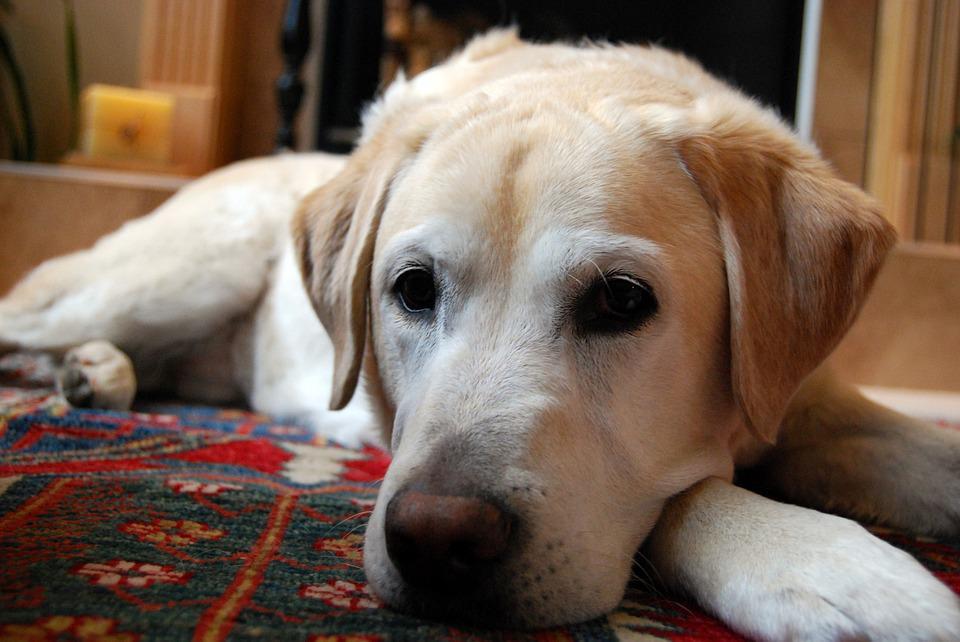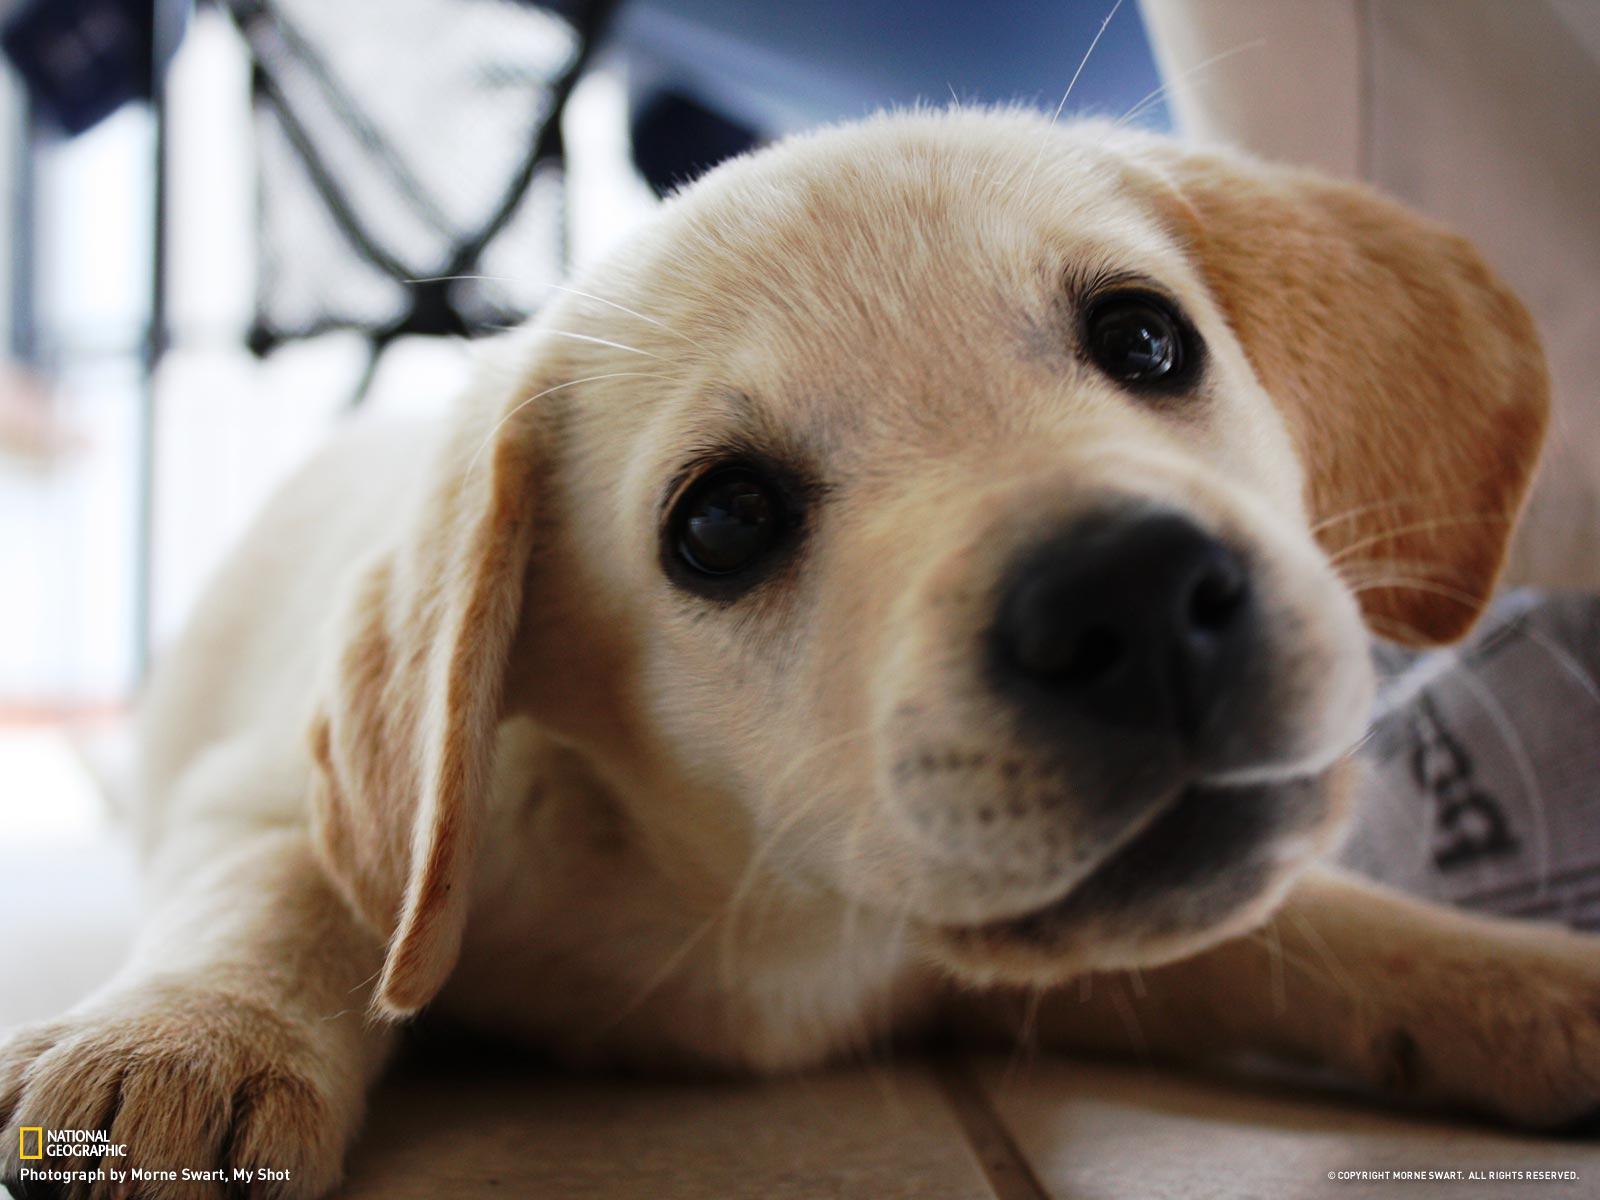The first image is the image on the left, the second image is the image on the right. For the images displayed, is the sentence "In one image in each pair an upright dog has something in its mouth." factually correct? Answer yes or no. No. 